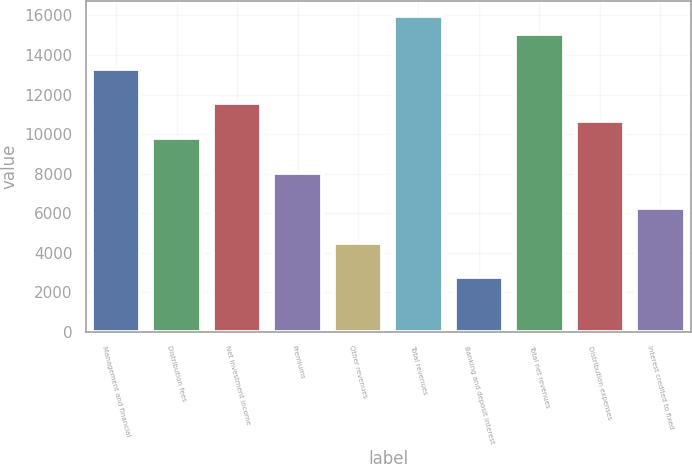<chart> <loc_0><loc_0><loc_500><loc_500><bar_chart><fcel>Management and financial<fcel>Distribution fees<fcel>Net investment income<fcel>Premiums<fcel>Other revenues<fcel>Total revenues<fcel>Banking and deposit interest<fcel>Total net revenues<fcel>Distribution expenses<fcel>Interest credited to fixed<nl><fcel>13307.5<fcel>9788.7<fcel>11548.1<fcel>8029.3<fcel>4510.5<fcel>15946.6<fcel>2751.1<fcel>15066.9<fcel>10668.4<fcel>6269.9<nl></chart> 